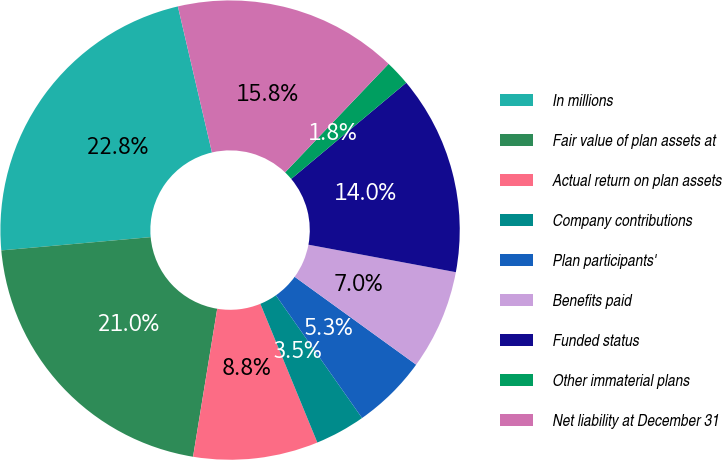Convert chart to OTSL. <chart><loc_0><loc_0><loc_500><loc_500><pie_chart><fcel>In millions<fcel>Fair value of plan assets at<fcel>Actual return on plan assets<fcel>Company contributions<fcel>Plan participants'<fcel>Benefits paid<fcel>Funded status<fcel>Other immaterial plans<fcel>Net liability at December 31<nl><fcel>22.76%<fcel>21.01%<fcel>8.78%<fcel>3.54%<fcel>5.29%<fcel>7.03%<fcel>14.02%<fcel>1.79%<fcel>15.77%<nl></chart> 